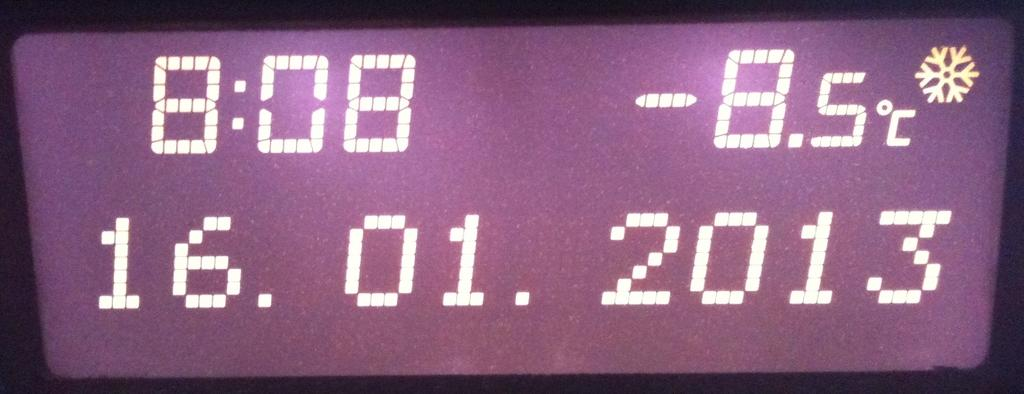<image>
Summarize the visual content of the image. Temperature reading that reads at 8:08, the temperature is at -8.5 degrees celcius. 